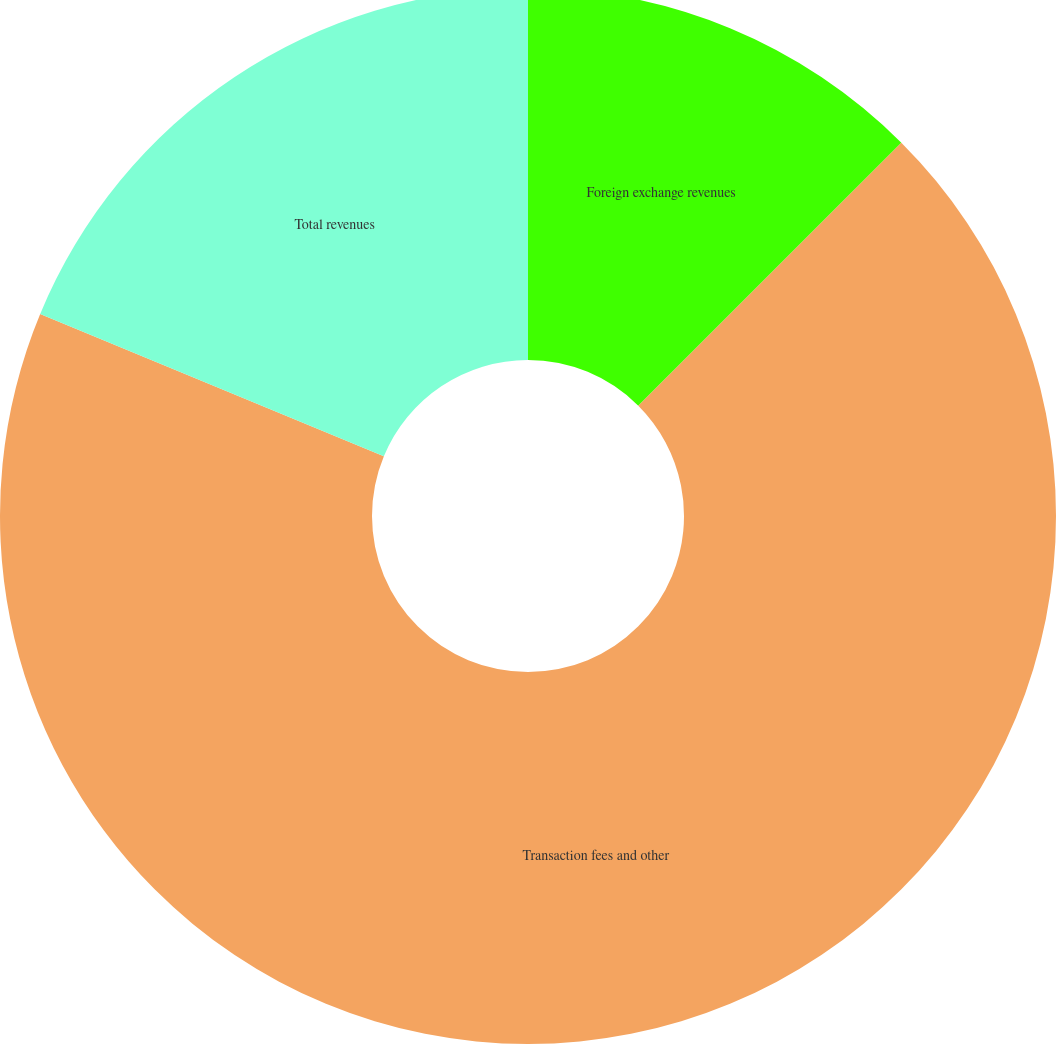Convert chart. <chart><loc_0><loc_0><loc_500><loc_500><pie_chart><fcel>Foreign exchange revenues<fcel>Transaction fees and other<fcel>Total revenues<nl><fcel>12.5%<fcel>68.75%<fcel>18.75%<nl></chart> 